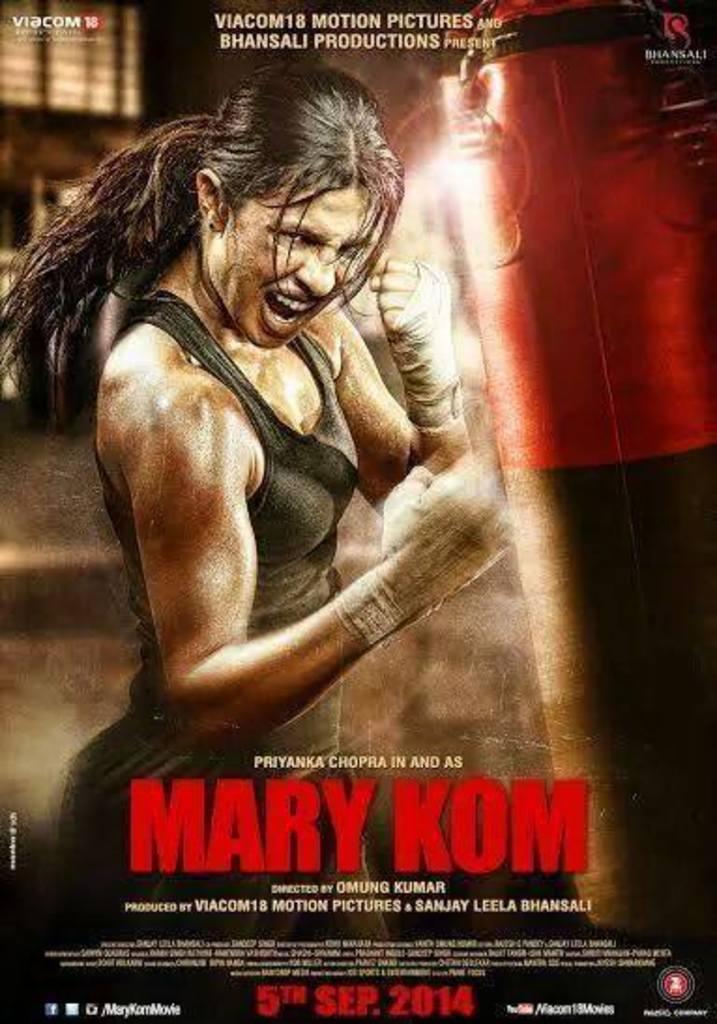What is mary's last name?
Offer a terse response. Kom. What date was this released?
Offer a very short reply. 5th sep 2014. 